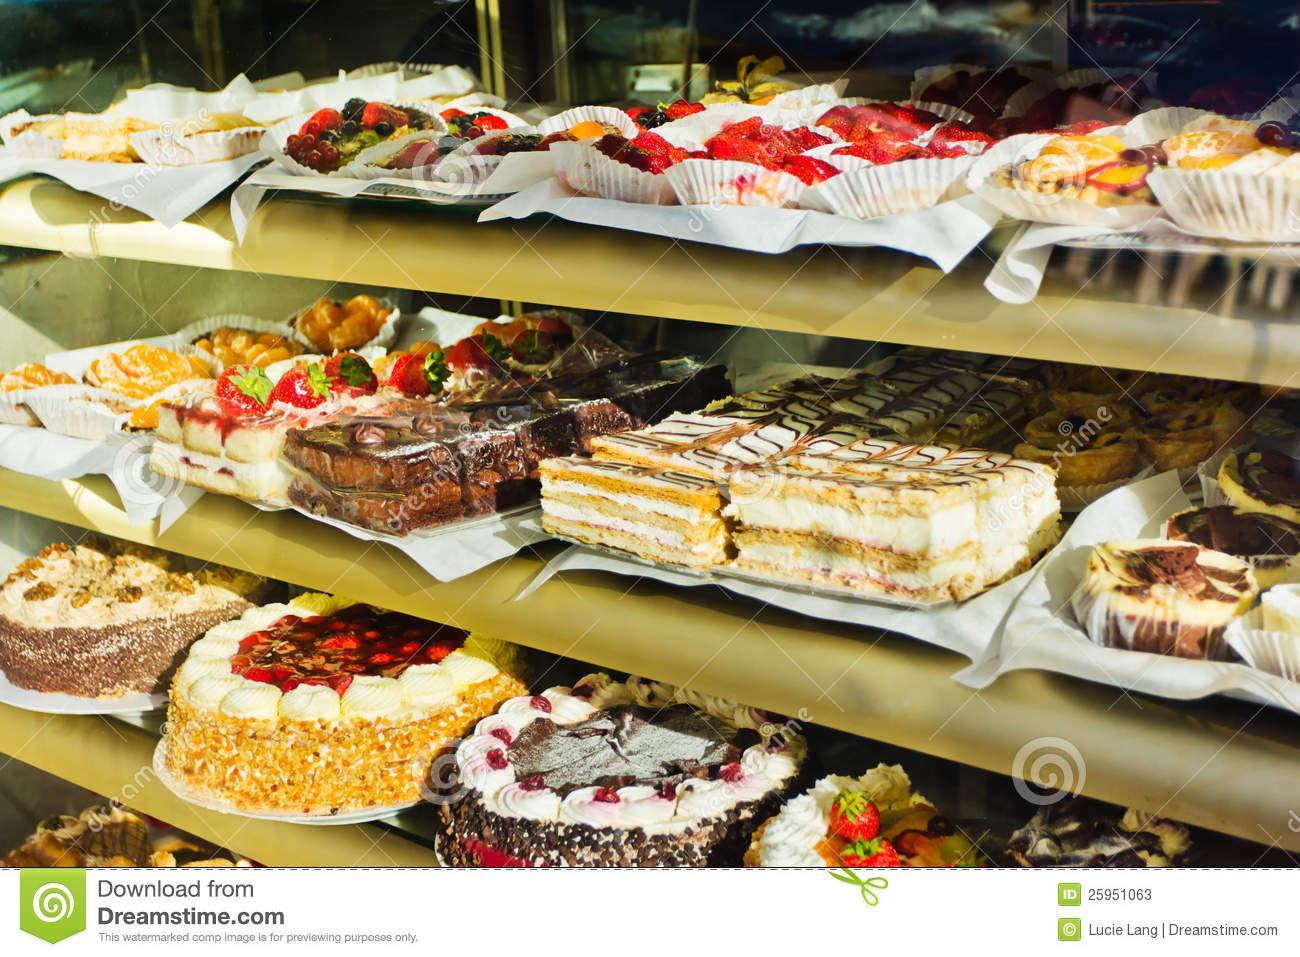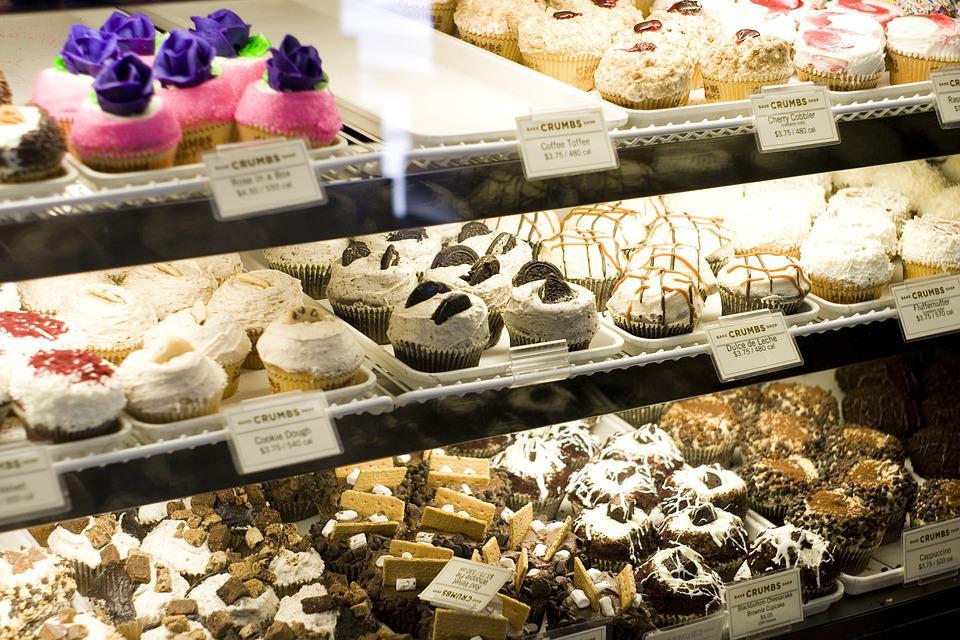The first image is the image on the left, the second image is the image on the right. Analyze the images presented: Is the assertion "The floor can be seen in one of the images." valid? Answer yes or no. No. 